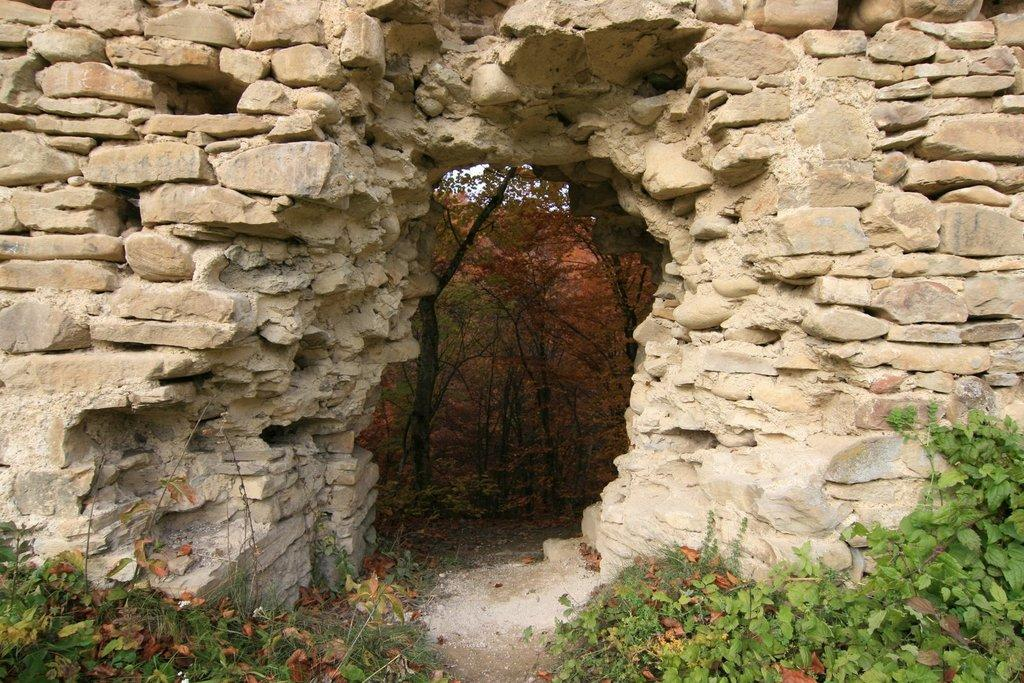What is the main structure in the center of the image? There is a stone arch in the center of the image. What type of vegetation is at the bottom of the image? There are plants at the bottom of the image. What can be seen in the background of the image? There are trees in the background of the image. What is the size of the theory in the image? There is no theory present in the image; it features a stone arch, plants, and trees. Can you tell me how many wars are depicted in the image? There are no wars depicted in the image; it is a scene with a stone arch, plants, and trees. 